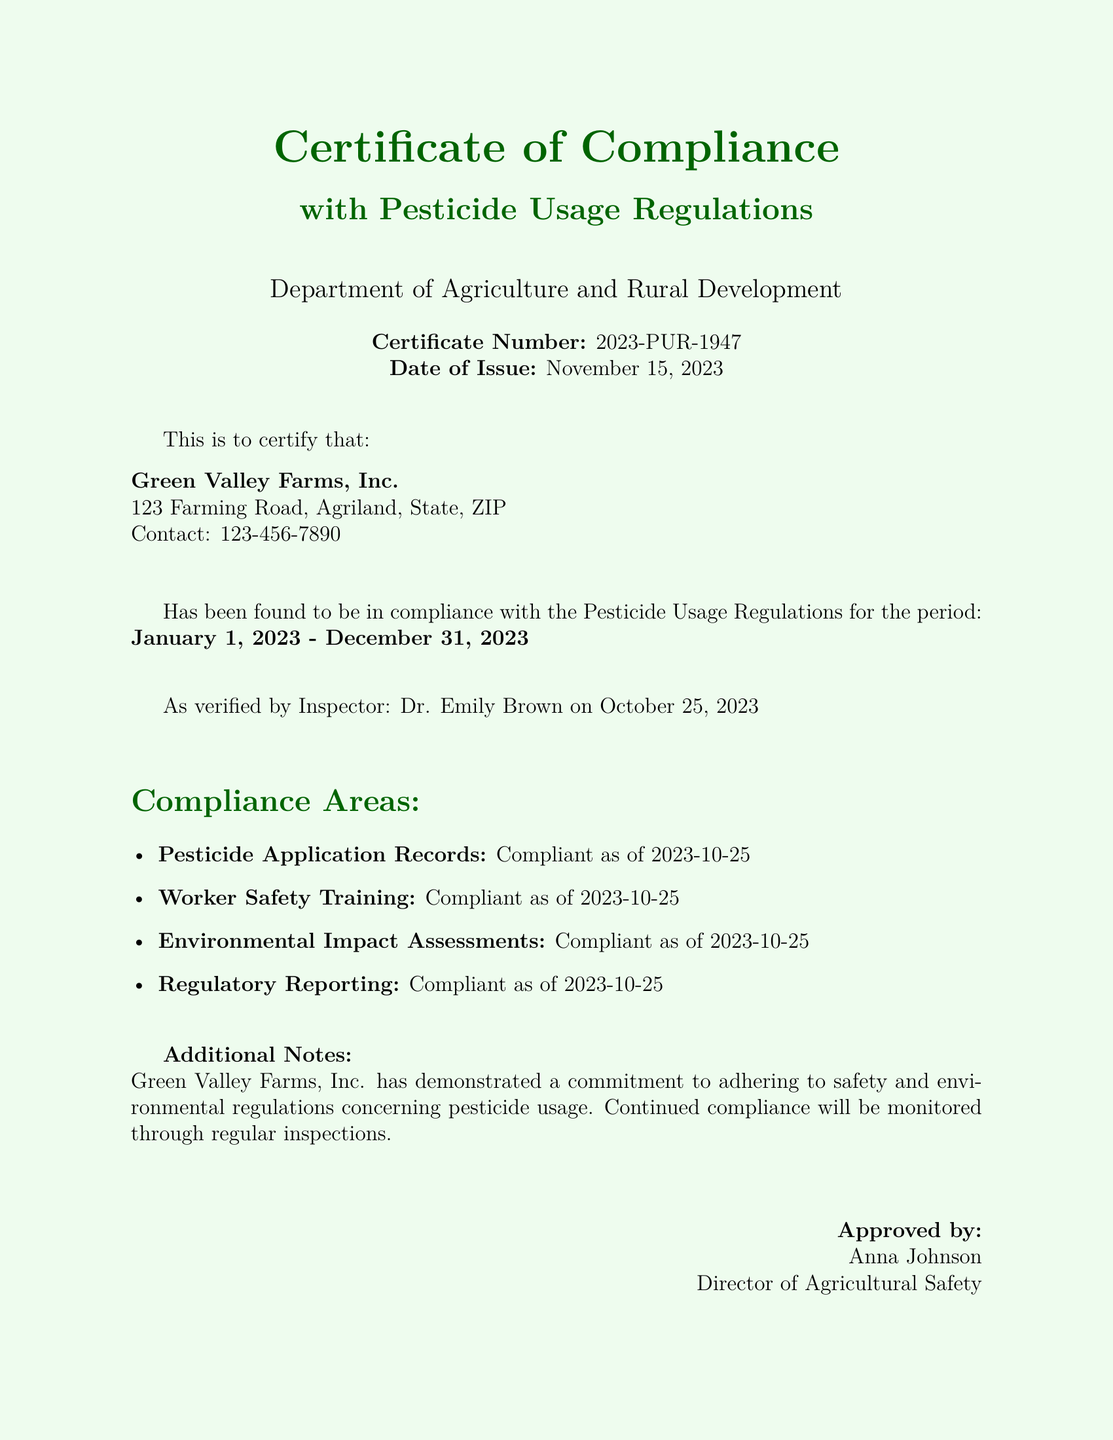What is the certificate number? The certificate number is a unique identifier for this compliance certificate, indicating its specific registration, which is 2023-PUR-1947.
Answer: 2023-PUR-1947 Who is the compliance inspector? The compliance inspector verified the adherence to pesticide regulations and is named in the document as Dr. Emily Brown.
Answer: Dr. Emily Brown When was the inspection conducted? The inspection date is noted in the document, indicating when the compliance was verified, which is October 25, 2023.
Answer: October 25, 2023 What is the period of compliance? The specified period during which the farm is compliant with the regulations is mentioned, which is from January 1, 2023 to December 31, 2023.
Answer: January 1, 2023 - December 31, 2023 What is the name of the farm? The certificate clearly states the name of the farm that has received this certification of compliance.
Answer: Green Valley Farms, Inc Which department issued the certificate? The department that is responsible for issuing the certificate is identified in the document, which is focused on agriculture.
Answer: Department of Agriculture and Rural Development What is the name of the Director of Agricultural Safety? The certificate identifies the individual who approved the compliance certification, which is vital for validation, named in the document as Anna Johnson.
Answer: Anna Johnson How many compliance areas are listed? By reviewing the list in the document, the total number of compliance areas that were evaluated can be counted.
Answer: 4 What are the compliance areas related to? The compliance areas reflect the various aspects of pesticide usage and safety.
Answer: Pesticide Application Records, Worker Safety Training, Environmental Impact Assessments, Regulatory Reporting 